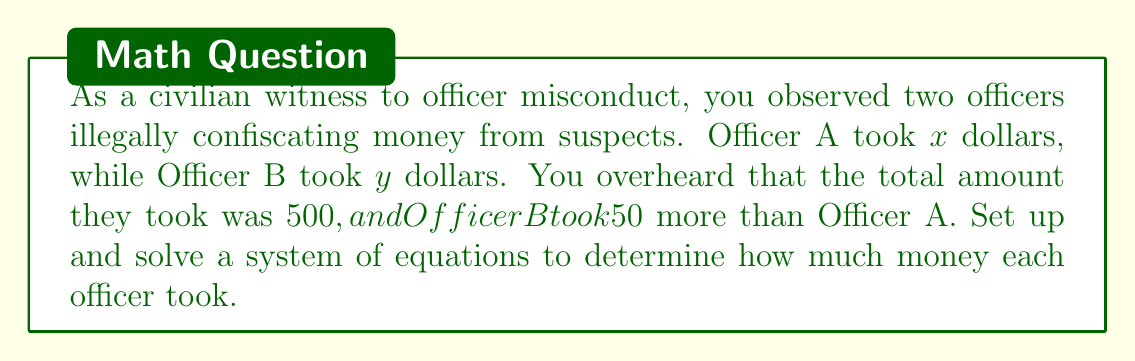Could you help me with this problem? Let's set up the system of equations based on the given information:

1. The total amount taken by both officers is $500:
   $$x + y = 500$$

2. Officer B took $50 more than Officer A:
   $$y = x + 50$$

Now, let's solve this system of equations:

1. Substitute the second equation into the first:
   $$x + (x + 50) = 500$$

2. Simplify:
   $$2x + 50 = 500$$

3. Subtract 50 from both sides:
   $$2x = 450$$

4. Divide both sides by 2:
   $$x = 225$$

5. Now that we know $x$, we can find $y$ using the second equation:
   $$y = x + 50 = 225 + 50 = 275$$

6. Verify the solution by checking both original equations:
   $$225 + 275 = 500$$ (true)
   $$275 = 225 + 50$$ (true)

Therefore, Officer A took $225 and Officer B took $275.
Answer: Officer A took $225, and Officer B took $275. 